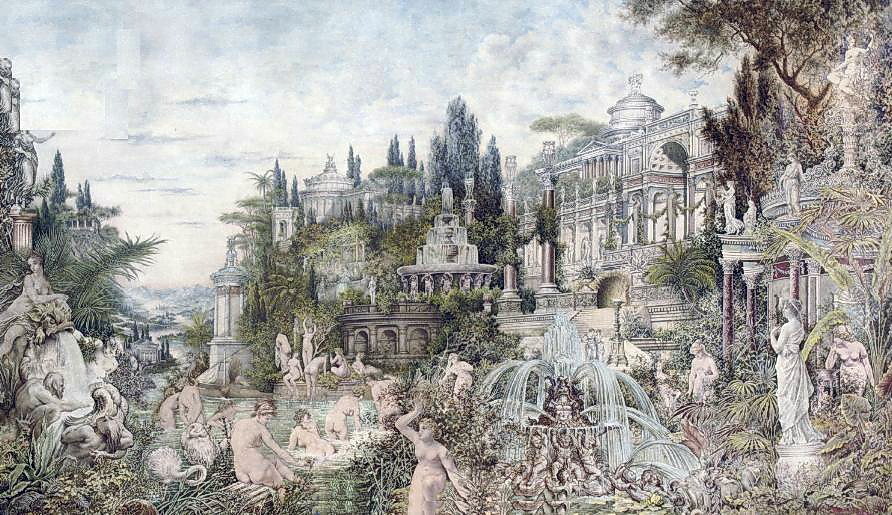Can you describe some of the mythological elements visible in the garden? The garden is rich with mythological references, featuring statues that likely represent figures from Greek and Roman mythology. For instance, you can spot what appears to be Apollo, the god of the arts and sun, alongside possibly Artemis, goddess of the hunt. These statues not only enhance the garden's aesthetic appeal but also evoke stories and themes from mythology, such as beauty, nature, and heroism, intertwining these with the natural world represented by the surrounding flora. What do these mythological figures add to the overall atmosphere of the garden? The presence of mythological figures significantly enriches the garden’s atmosphere, lending an air of ancient grandeur and timeless elegance. They serve as a bridge to the past, transforming the garden into a place where visitors can momentarily step into a world of gods and goddesses. This adds depth to the visual experience, suggesting a space where beauty and history converge, creating a tranquil yet evocative environment perfect for reflection and admiration. 